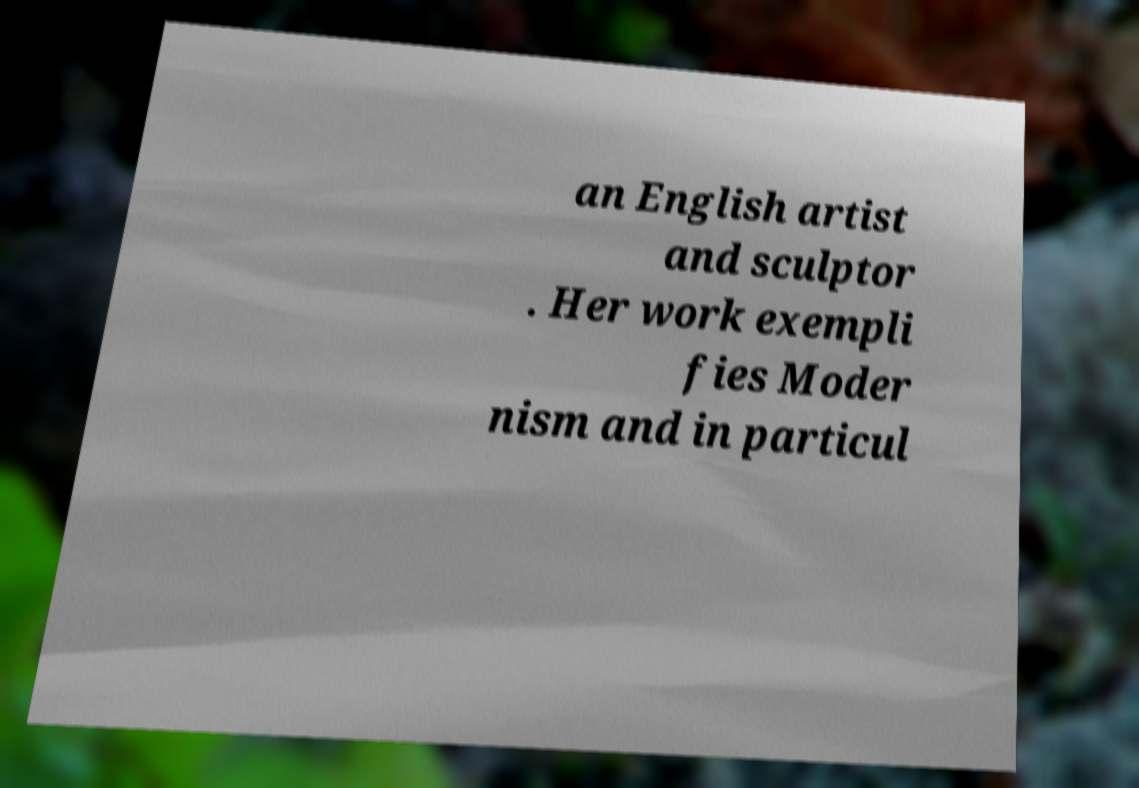Could you extract and type out the text from this image? an English artist and sculptor . Her work exempli fies Moder nism and in particul 